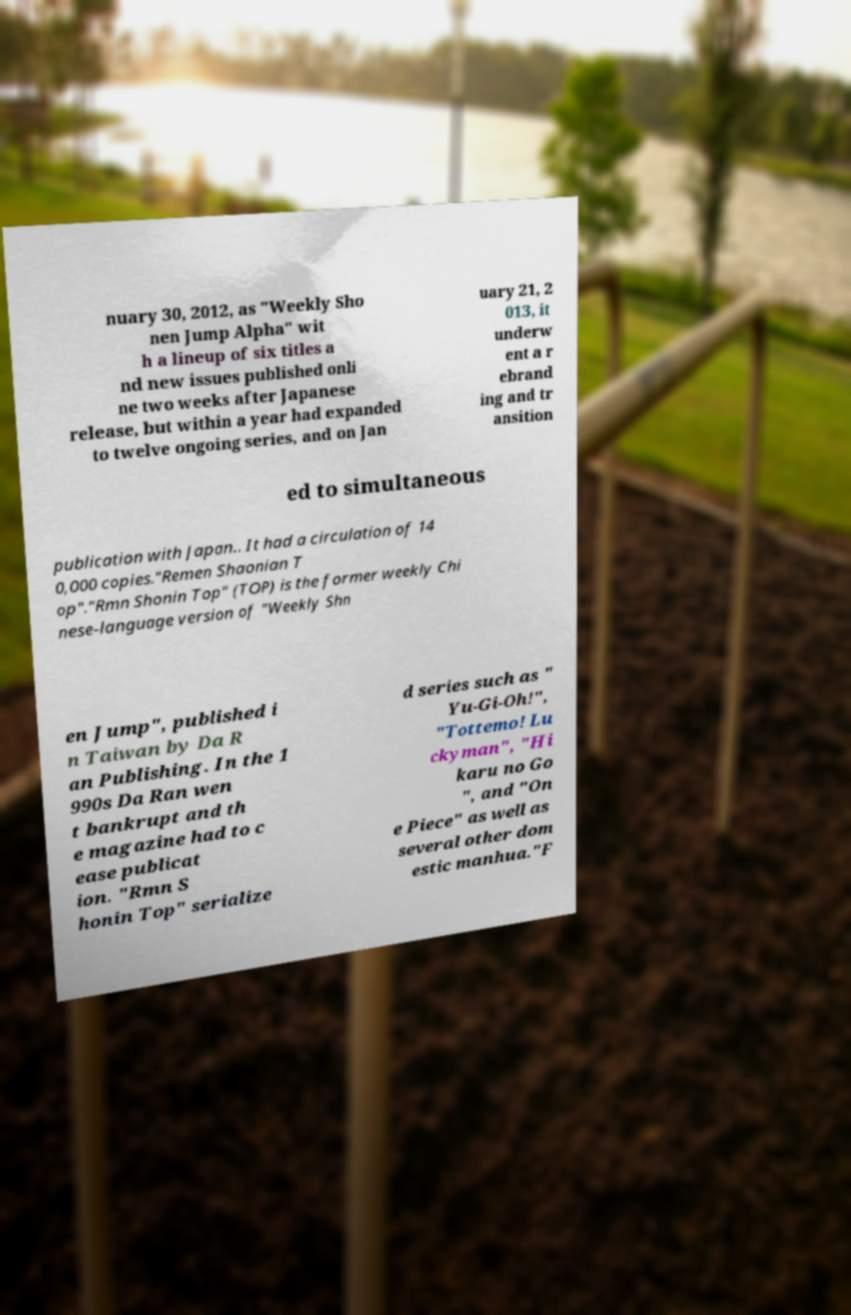Could you assist in decoding the text presented in this image and type it out clearly? nuary 30, 2012, as "Weekly Sho nen Jump Alpha" wit h a lineup of six titles a nd new issues published onli ne two weeks after Japanese release, but within a year had expanded to twelve ongoing series, and on Jan uary 21, 2 013, it underw ent a r ebrand ing and tr ansition ed to simultaneous publication with Japan.. It had a circulation of 14 0,000 copies."Remen Shaonian T op"."Rmn Shonin Top" (TOP) is the former weekly Chi nese-language version of "Weekly Shn en Jump", published i n Taiwan by Da R an Publishing. In the 1 990s Da Ran wen t bankrupt and th e magazine had to c ease publicat ion. "Rmn S honin Top" serialize d series such as " Yu-Gi-Oh!", "Tottemo! Lu ckyman", "Hi karu no Go ", and "On e Piece" as well as several other dom estic manhua."F 